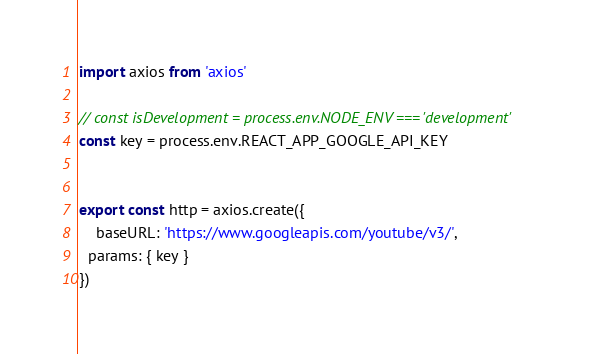Convert code to text. <code><loc_0><loc_0><loc_500><loc_500><_JavaScript_>import axios from 'axios'

// const isDevelopment = process.env.NODE_ENV === 'development'
const key = process.env.REACT_APP_GOOGLE_API_KEY


export const http = axios.create({
	baseURL: 'https://www.googleapis.com/youtube/v3/',
  params: { key }
})
</code> 